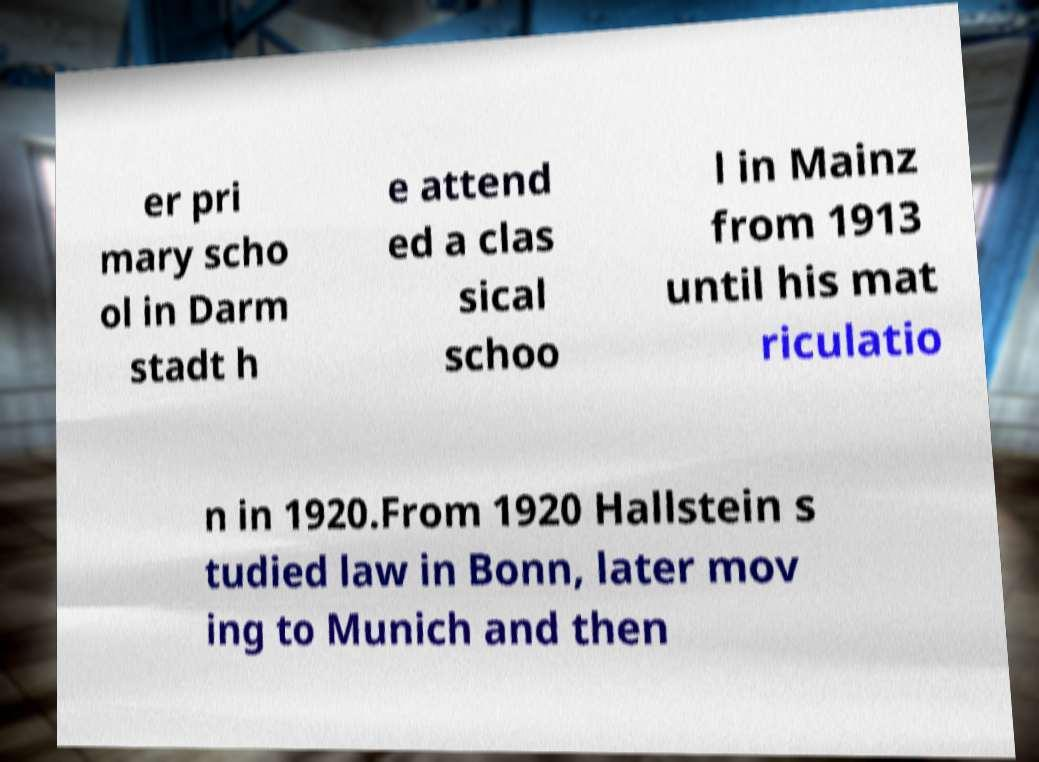Please read and relay the text visible in this image. What does it say? er pri mary scho ol in Darm stadt h e attend ed a clas sical schoo l in Mainz from 1913 until his mat riculatio n in 1920.From 1920 Hallstein s tudied law in Bonn, later mov ing to Munich and then 